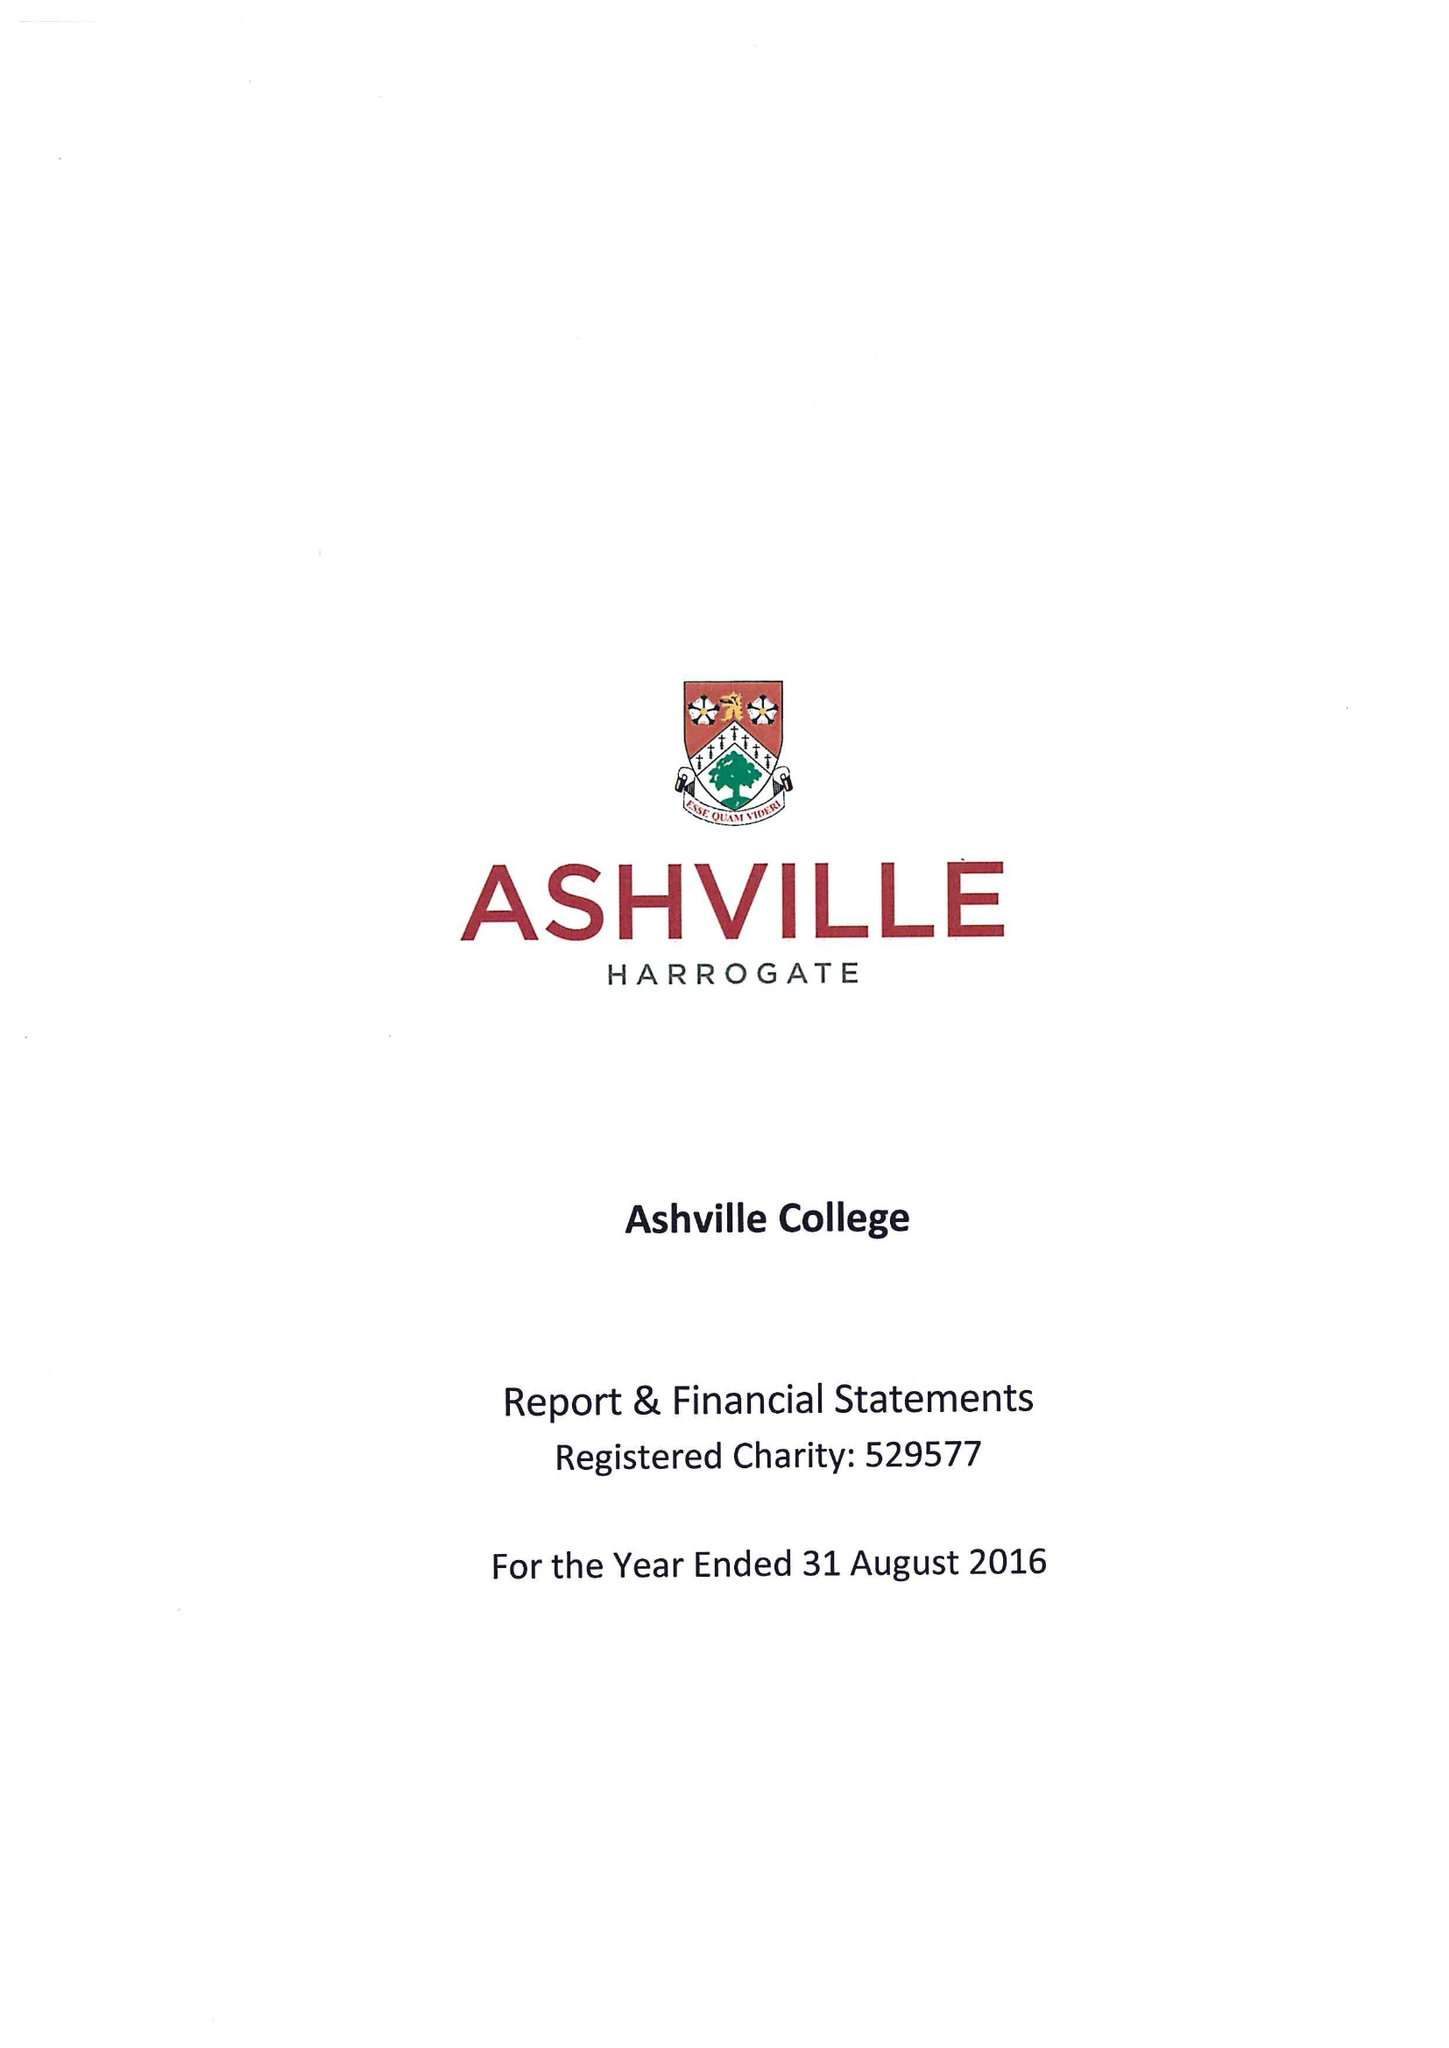What is the value for the report_date?
Answer the question using a single word or phrase. 2016-08-31 